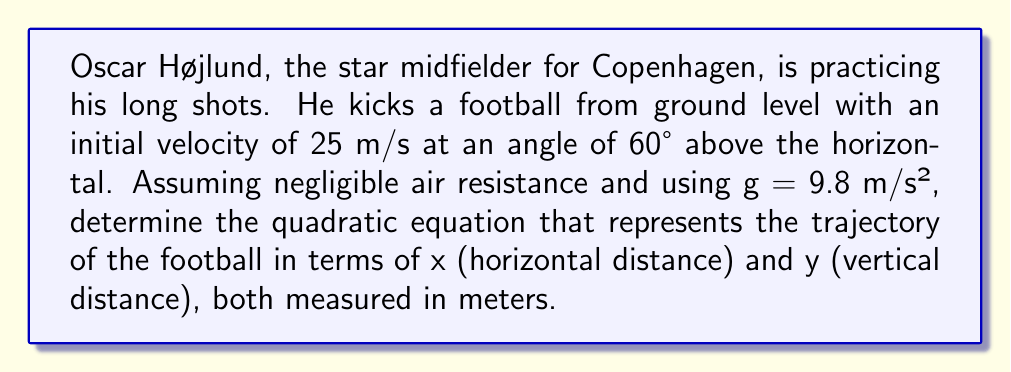Help me with this question. To solve this problem, we'll use the equations of motion for projectile motion and derive the quadratic equation for the trajectory.

1. First, let's break down the initial velocity into its horizontal and vertical components:
   $v_{0x} = v_0 \cos \theta = 25 \cos 60° = 12.5$ m/s
   $v_{0y} = v_0 \sin \theta = 25 \sin 60° = 21.65$ m/s

2. The horizontal motion equation: $x = v_{0x}t$

3. The vertical motion equation: $y = v_{0y}t - \frac{1}{2}gt^2$

4. We want to eliminate time (t) to get y in terms of x. From the horizontal motion equation:
   $t = \frac{x}{v_{0x}}$

5. Substituting this into the vertical motion equation:
   $y = v_{0y}(\frac{x}{v_{0x}}) - \frac{1}{2}g(\frac{x}{v_{0x}})^2$

6. Simplify:
   $y = \frac{v_{0y}}{v_{0x}}x - \frac{g}{2(v_{0x})^2}x^2$

7. Substitute the values:
   $y = \frac{21.65}{12.5}x - \frac{9.8}{2(12.5)^2}x^2$

8. Simplify further:
   $y = 1.732x - 0.03136x^2$

This is the quadratic equation representing the trajectory of the football.
Answer: $y = 1.732x - 0.03136x^2$ 